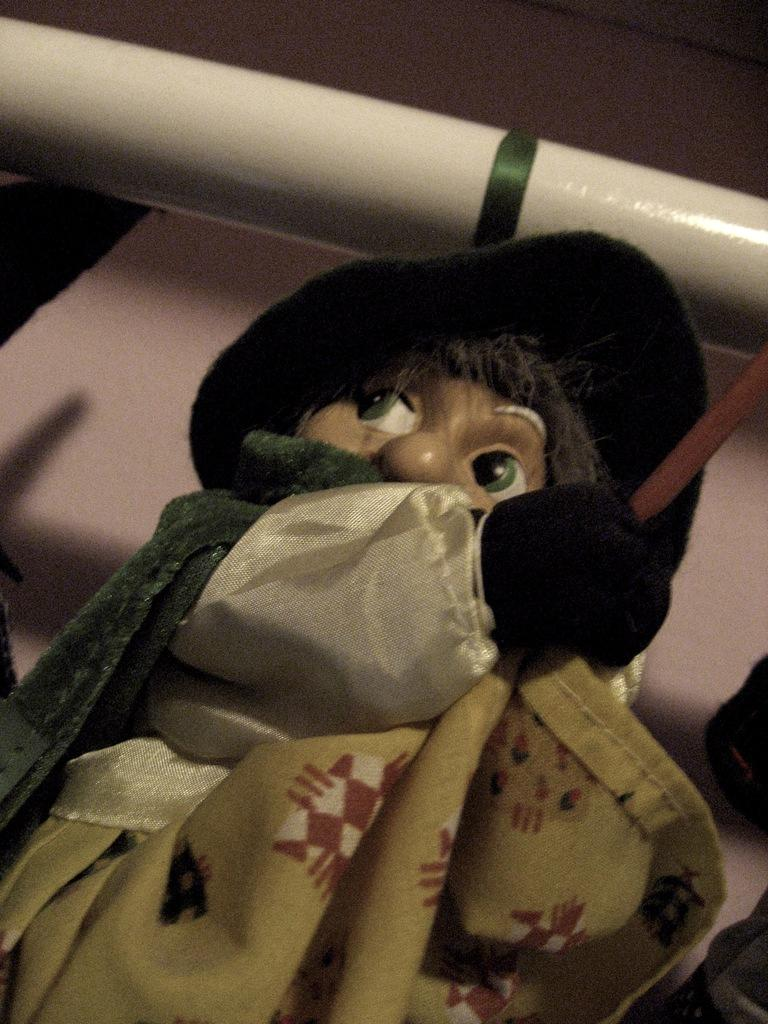What object is present in the image that resembles a toy? There is a toy in the image. What is the toy wearing? The toy has a dress on it. What other object can be seen in the image? There is a pole visible in the image. What is the woman's desire for the toy in the image? There is no woman present in the image, so it is not possible to determine her desire for the toy. 